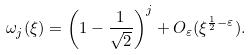<formula> <loc_0><loc_0><loc_500><loc_500>\omega _ { j } ( \xi ) = \left ( 1 - \frac { 1 } { \sqrt { 2 } } \right ) ^ { j } + O _ { \varepsilon } ( \xi ^ { \frac { 1 } { 2 } - \varepsilon } ) .</formula> 